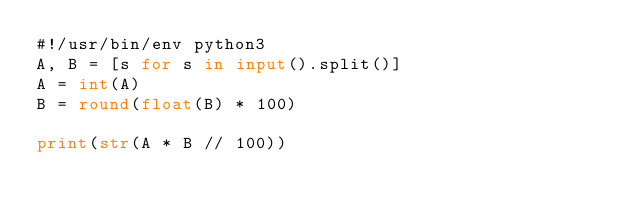<code> <loc_0><loc_0><loc_500><loc_500><_Python_>#!/usr/bin/env python3
A, B = [s for s in input().split()]
A = int(A)
B = round(float(B) * 100)

print(str(A * B // 100))
</code> 